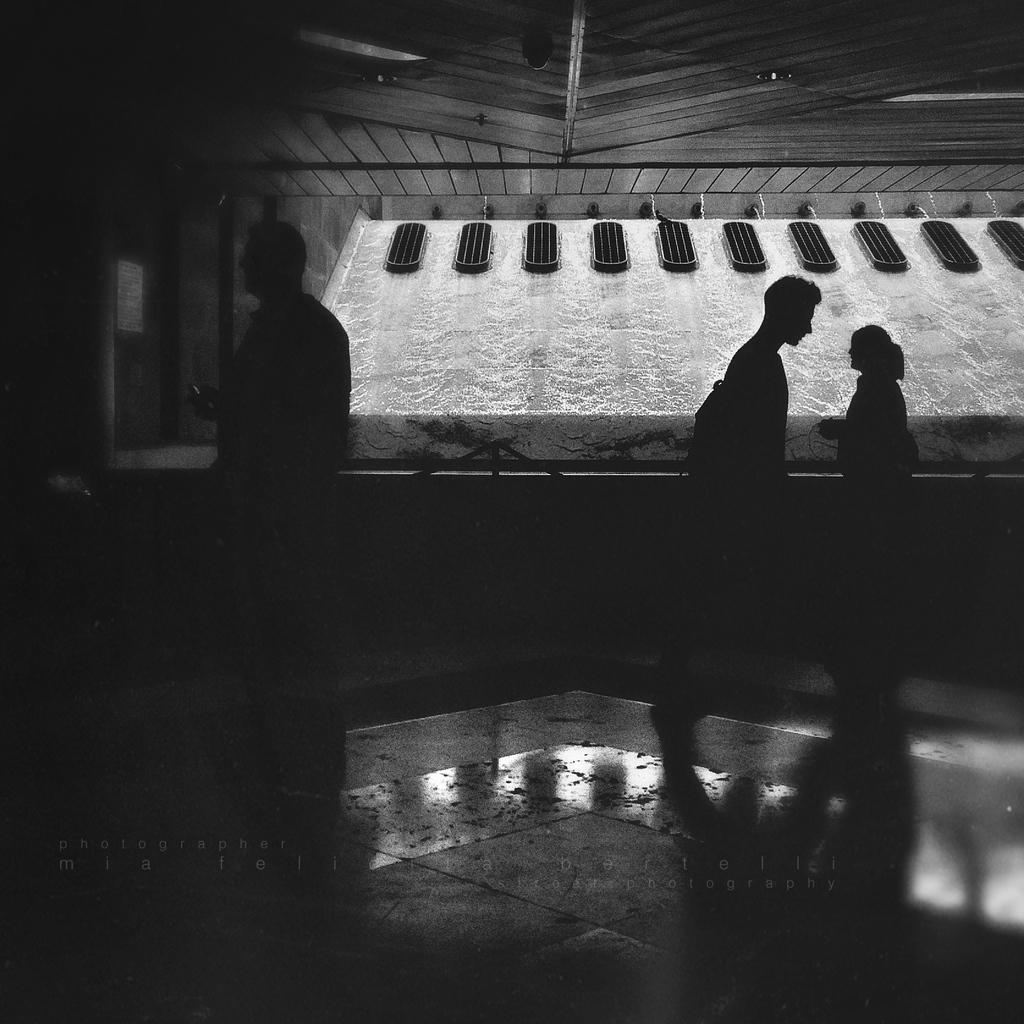How many people are in the image? There are three persons in the image. What are the persons doing in the image? The persons are on the floor. What can be seen in the middle of the image? There is an object in the middle of the image. What color is the surprise in the image? There is no surprise present in the image, so it cannot be described by color. 